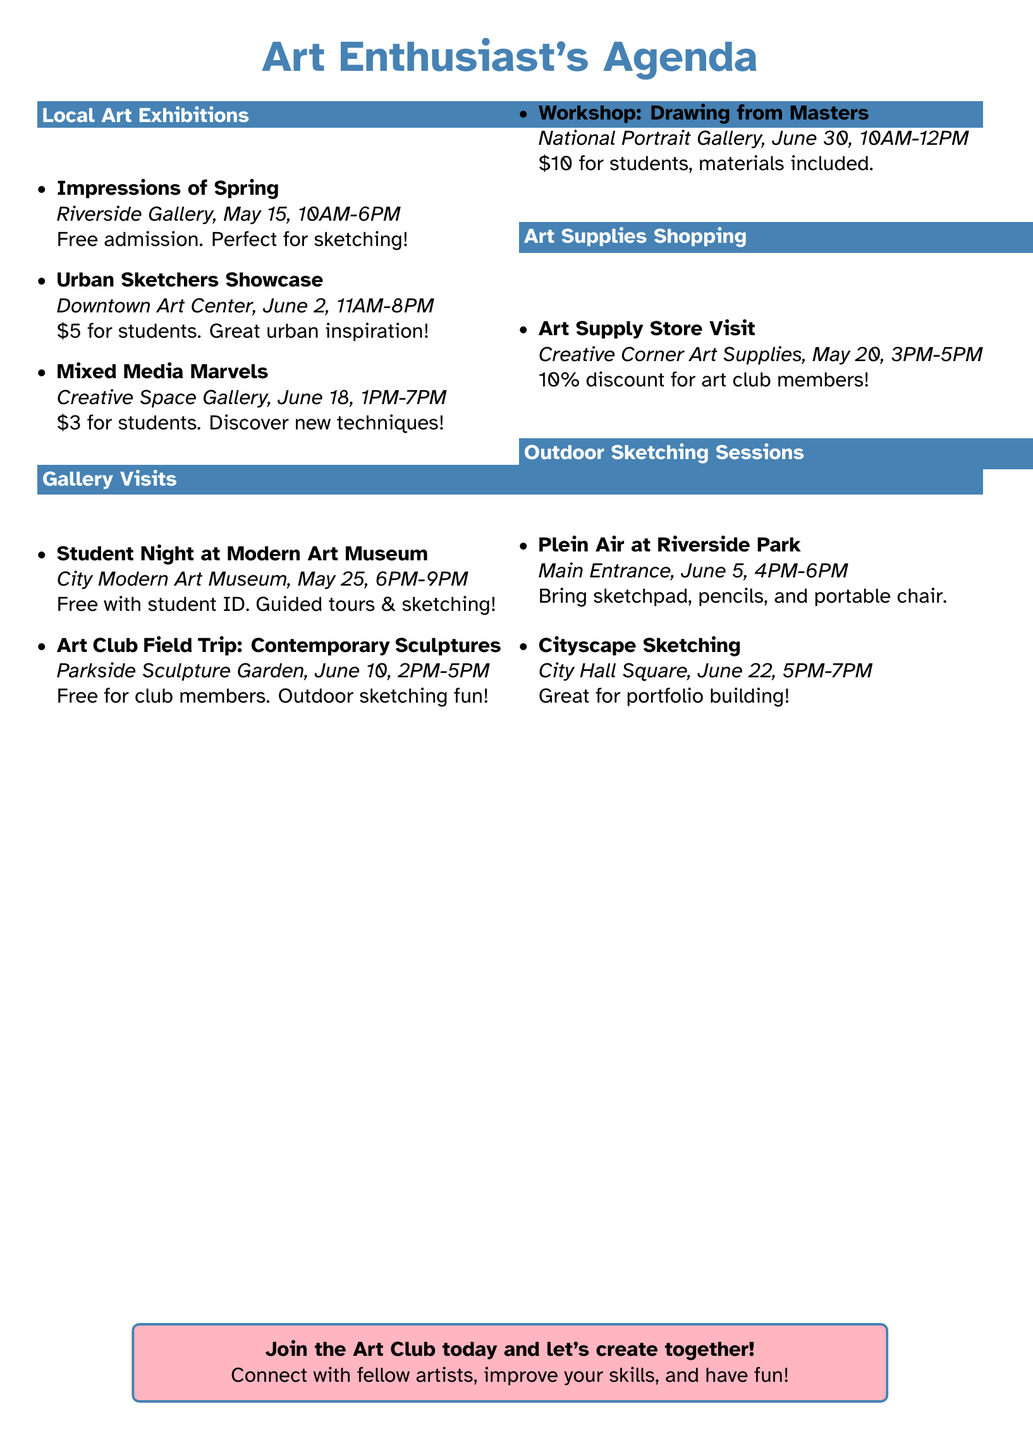What is the name of the first exhibition? The first exhibition listed is "Impressions of Spring" at Riverside Gallery.
Answer: Impressions of Spring When does the Urban Sketchers Showcase start? The Urban Sketchers Showcase starts at 11:00 AM on June 2, 2023.
Answer: 11:00 AM How much does the Workshop: Drawing from Masters cost for students? The Workshop costs $10 for students and includes materials.
Answer: $10 What is the venue for the Art Club Field Trip? The Art Club Field Trip is held at Parkside Sculpture Garden.
Answer: Parkside Sculpture Garden Which outdoor sketching session is on June 22? The outdoor sketching session on June 22 is called "Cityscape Sketching."
Answer: Cityscape Sketching What is required for the Plein Air at Riverside Park session? Participants need to bring a sketchpad, pencils, and optionally a portable chair.
Answer: Sketchpad, pencils, and portable chair How long is the Student Night at Modern Art Museum? The Student Night lasts for 3 hours, from 6:00 PM to 9:00 PM.
Answer: 3 hours What day is the Art Supply Store Visit scheduled? The Art Supply Store Visit is scheduled for May 20, 2023.
Answer: May 20, 2023 What does the workshop provide to students? The workshop provides materials for students to use during the session.
Answer: Materials 